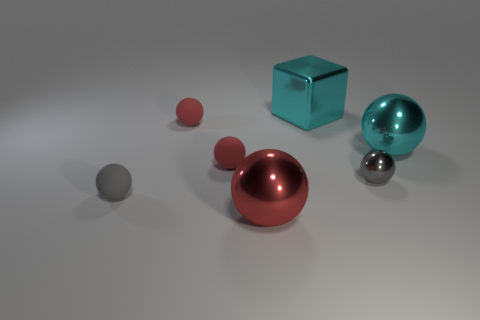What material is the other thing that is the same color as the tiny metallic object?
Offer a very short reply. Rubber. There is a large cyan object that is the same shape as the red metal thing; what material is it?
Your response must be concise. Metal. There is a gray object that is left of the small metallic ball; is it the same shape as the big cyan shiny thing that is behind the large cyan sphere?
Keep it short and to the point. No. Are there fewer gray spheres to the left of the small gray metallic object than tiny things in front of the cyan sphere?
Your answer should be very brief. Yes. What number of other objects are there of the same shape as the gray metal object?
Your answer should be compact. 5. The large cyan thing that is made of the same material as the cyan sphere is what shape?
Offer a terse response. Cube. There is a object that is both right of the large block and in front of the big cyan ball; what color is it?
Keep it short and to the point. Gray. Does the gray sphere on the right side of the big red object have the same material as the big red thing?
Your answer should be compact. Yes. Is the number of big cyan metal cubes that are in front of the tiny gray metal ball less than the number of purple rubber cubes?
Provide a succinct answer. No. Is there another sphere that has the same material as the big red sphere?
Offer a terse response. Yes. 